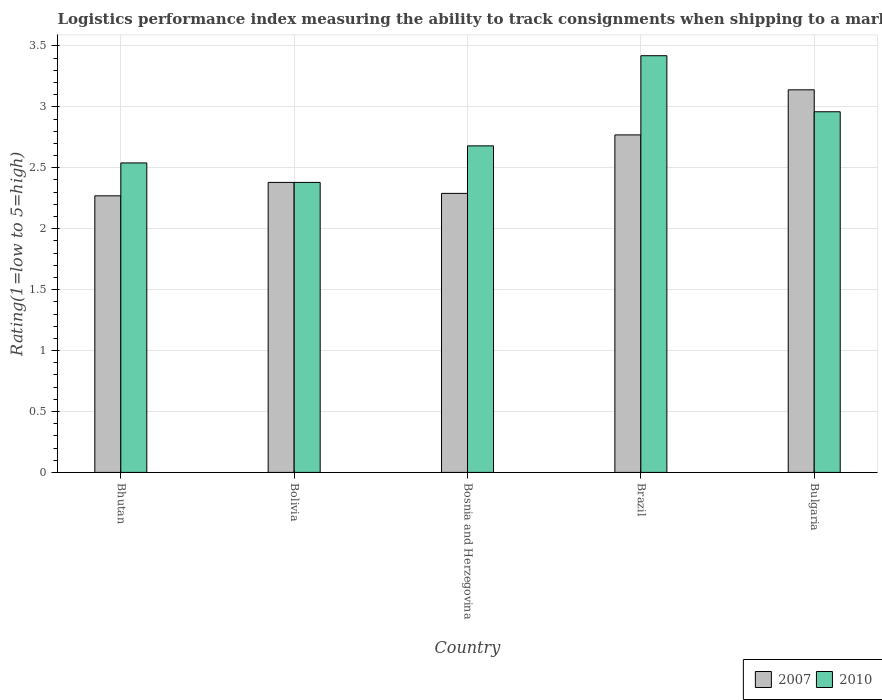How many different coloured bars are there?
Give a very brief answer. 2. How many groups of bars are there?
Offer a very short reply. 5. Are the number of bars on each tick of the X-axis equal?
Your response must be concise. Yes. How many bars are there on the 3rd tick from the right?
Provide a succinct answer. 2. In how many cases, is the number of bars for a given country not equal to the number of legend labels?
Your answer should be very brief. 0. What is the Logistic performance index in 2007 in Bulgaria?
Make the answer very short. 3.14. Across all countries, what is the maximum Logistic performance index in 2010?
Your response must be concise. 3.42. Across all countries, what is the minimum Logistic performance index in 2007?
Give a very brief answer. 2.27. In which country was the Logistic performance index in 2010 minimum?
Provide a succinct answer. Bolivia. What is the total Logistic performance index in 2010 in the graph?
Offer a terse response. 13.98. What is the difference between the Logistic performance index in 2007 in Bhutan and that in Bolivia?
Provide a short and direct response. -0.11. What is the difference between the Logistic performance index in 2007 in Bhutan and the Logistic performance index in 2010 in Brazil?
Provide a short and direct response. -1.15. What is the average Logistic performance index in 2007 per country?
Make the answer very short. 2.57. What is the difference between the Logistic performance index of/in 2007 and Logistic performance index of/in 2010 in Brazil?
Your response must be concise. -0.65. In how many countries, is the Logistic performance index in 2007 greater than 0.1?
Keep it short and to the point. 5. What is the ratio of the Logistic performance index in 2007 in Bolivia to that in Bulgaria?
Your response must be concise. 0.76. Is the Logistic performance index in 2007 in Bosnia and Herzegovina less than that in Bulgaria?
Provide a short and direct response. Yes. What is the difference between the highest and the second highest Logistic performance index in 2010?
Provide a succinct answer. -0.28. What is the difference between the highest and the lowest Logistic performance index in 2007?
Provide a succinct answer. 0.87. In how many countries, is the Logistic performance index in 2007 greater than the average Logistic performance index in 2007 taken over all countries?
Provide a short and direct response. 2. What does the 1st bar from the left in Bulgaria represents?
Provide a short and direct response. 2007. How many countries are there in the graph?
Ensure brevity in your answer.  5. Are the values on the major ticks of Y-axis written in scientific E-notation?
Give a very brief answer. No. How many legend labels are there?
Make the answer very short. 2. How are the legend labels stacked?
Offer a very short reply. Horizontal. What is the title of the graph?
Your response must be concise. Logistics performance index measuring the ability to track consignments when shipping to a market. What is the label or title of the Y-axis?
Offer a terse response. Rating(1=low to 5=high). What is the Rating(1=low to 5=high) of 2007 in Bhutan?
Keep it short and to the point. 2.27. What is the Rating(1=low to 5=high) in 2010 in Bhutan?
Ensure brevity in your answer.  2.54. What is the Rating(1=low to 5=high) in 2007 in Bolivia?
Your answer should be very brief. 2.38. What is the Rating(1=low to 5=high) of 2010 in Bolivia?
Ensure brevity in your answer.  2.38. What is the Rating(1=low to 5=high) in 2007 in Bosnia and Herzegovina?
Provide a short and direct response. 2.29. What is the Rating(1=low to 5=high) in 2010 in Bosnia and Herzegovina?
Make the answer very short. 2.68. What is the Rating(1=low to 5=high) of 2007 in Brazil?
Make the answer very short. 2.77. What is the Rating(1=low to 5=high) of 2010 in Brazil?
Ensure brevity in your answer.  3.42. What is the Rating(1=low to 5=high) of 2007 in Bulgaria?
Make the answer very short. 3.14. What is the Rating(1=low to 5=high) in 2010 in Bulgaria?
Provide a succinct answer. 2.96. Across all countries, what is the maximum Rating(1=low to 5=high) of 2007?
Provide a succinct answer. 3.14. Across all countries, what is the maximum Rating(1=low to 5=high) of 2010?
Your answer should be compact. 3.42. Across all countries, what is the minimum Rating(1=low to 5=high) of 2007?
Ensure brevity in your answer.  2.27. Across all countries, what is the minimum Rating(1=low to 5=high) of 2010?
Provide a short and direct response. 2.38. What is the total Rating(1=low to 5=high) of 2007 in the graph?
Give a very brief answer. 12.85. What is the total Rating(1=low to 5=high) of 2010 in the graph?
Give a very brief answer. 13.98. What is the difference between the Rating(1=low to 5=high) of 2007 in Bhutan and that in Bolivia?
Give a very brief answer. -0.11. What is the difference between the Rating(1=low to 5=high) of 2010 in Bhutan and that in Bolivia?
Your answer should be compact. 0.16. What is the difference between the Rating(1=low to 5=high) in 2007 in Bhutan and that in Bosnia and Herzegovina?
Your answer should be very brief. -0.02. What is the difference between the Rating(1=low to 5=high) in 2010 in Bhutan and that in Bosnia and Herzegovina?
Your response must be concise. -0.14. What is the difference between the Rating(1=low to 5=high) in 2007 in Bhutan and that in Brazil?
Offer a terse response. -0.5. What is the difference between the Rating(1=low to 5=high) in 2010 in Bhutan and that in Brazil?
Your answer should be compact. -0.88. What is the difference between the Rating(1=low to 5=high) of 2007 in Bhutan and that in Bulgaria?
Your response must be concise. -0.87. What is the difference between the Rating(1=low to 5=high) in 2010 in Bhutan and that in Bulgaria?
Offer a terse response. -0.42. What is the difference between the Rating(1=low to 5=high) in 2007 in Bolivia and that in Bosnia and Herzegovina?
Provide a short and direct response. 0.09. What is the difference between the Rating(1=low to 5=high) in 2010 in Bolivia and that in Bosnia and Herzegovina?
Your answer should be very brief. -0.3. What is the difference between the Rating(1=low to 5=high) of 2007 in Bolivia and that in Brazil?
Your answer should be compact. -0.39. What is the difference between the Rating(1=low to 5=high) of 2010 in Bolivia and that in Brazil?
Your response must be concise. -1.04. What is the difference between the Rating(1=low to 5=high) in 2007 in Bolivia and that in Bulgaria?
Your answer should be very brief. -0.76. What is the difference between the Rating(1=low to 5=high) in 2010 in Bolivia and that in Bulgaria?
Offer a terse response. -0.58. What is the difference between the Rating(1=low to 5=high) in 2007 in Bosnia and Herzegovina and that in Brazil?
Provide a short and direct response. -0.48. What is the difference between the Rating(1=low to 5=high) in 2010 in Bosnia and Herzegovina and that in Brazil?
Provide a succinct answer. -0.74. What is the difference between the Rating(1=low to 5=high) in 2007 in Bosnia and Herzegovina and that in Bulgaria?
Make the answer very short. -0.85. What is the difference between the Rating(1=low to 5=high) of 2010 in Bosnia and Herzegovina and that in Bulgaria?
Offer a very short reply. -0.28. What is the difference between the Rating(1=low to 5=high) of 2007 in Brazil and that in Bulgaria?
Make the answer very short. -0.37. What is the difference between the Rating(1=low to 5=high) of 2010 in Brazil and that in Bulgaria?
Ensure brevity in your answer.  0.46. What is the difference between the Rating(1=low to 5=high) in 2007 in Bhutan and the Rating(1=low to 5=high) in 2010 in Bolivia?
Your response must be concise. -0.11. What is the difference between the Rating(1=low to 5=high) in 2007 in Bhutan and the Rating(1=low to 5=high) in 2010 in Bosnia and Herzegovina?
Offer a terse response. -0.41. What is the difference between the Rating(1=low to 5=high) in 2007 in Bhutan and the Rating(1=low to 5=high) in 2010 in Brazil?
Offer a terse response. -1.15. What is the difference between the Rating(1=low to 5=high) of 2007 in Bhutan and the Rating(1=low to 5=high) of 2010 in Bulgaria?
Your response must be concise. -0.69. What is the difference between the Rating(1=low to 5=high) of 2007 in Bolivia and the Rating(1=low to 5=high) of 2010 in Brazil?
Your answer should be compact. -1.04. What is the difference between the Rating(1=low to 5=high) in 2007 in Bolivia and the Rating(1=low to 5=high) in 2010 in Bulgaria?
Your answer should be very brief. -0.58. What is the difference between the Rating(1=low to 5=high) in 2007 in Bosnia and Herzegovina and the Rating(1=low to 5=high) in 2010 in Brazil?
Provide a succinct answer. -1.13. What is the difference between the Rating(1=low to 5=high) in 2007 in Bosnia and Herzegovina and the Rating(1=low to 5=high) in 2010 in Bulgaria?
Offer a terse response. -0.67. What is the difference between the Rating(1=low to 5=high) of 2007 in Brazil and the Rating(1=low to 5=high) of 2010 in Bulgaria?
Your answer should be very brief. -0.19. What is the average Rating(1=low to 5=high) in 2007 per country?
Provide a short and direct response. 2.57. What is the average Rating(1=low to 5=high) of 2010 per country?
Offer a terse response. 2.8. What is the difference between the Rating(1=low to 5=high) in 2007 and Rating(1=low to 5=high) in 2010 in Bhutan?
Provide a short and direct response. -0.27. What is the difference between the Rating(1=low to 5=high) of 2007 and Rating(1=low to 5=high) of 2010 in Bolivia?
Offer a very short reply. 0. What is the difference between the Rating(1=low to 5=high) of 2007 and Rating(1=low to 5=high) of 2010 in Bosnia and Herzegovina?
Offer a very short reply. -0.39. What is the difference between the Rating(1=low to 5=high) of 2007 and Rating(1=low to 5=high) of 2010 in Brazil?
Give a very brief answer. -0.65. What is the difference between the Rating(1=low to 5=high) in 2007 and Rating(1=low to 5=high) in 2010 in Bulgaria?
Give a very brief answer. 0.18. What is the ratio of the Rating(1=low to 5=high) of 2007 in Bhutan to that in Bolivia?
Offer a terse response. 0.95. What is the ratio of the Rating(1=low to 5=high) in 2010 in Bhutan to that in Bolivia?
Offer a terse response. 1.07. What is the ratio of the Rating(1=low to 5=high) in 2007 in Bhutan to that in Bosnia and Herzegovina?
Give a very brief answer. 0.99. What is the ratio of the Rating(1=low to 5=high) in 2010 in Bhutan to that in Bosnia and Herzegovina?
Provide a succinct answer. 0.95. What is the ratio of the Rating(1=low to 5=high) of 2007 in Bhutan to that in Brazil?
Ensure brevity in your answer.  0.82. What is the ratio of the Rating(1=low to 5=high) in 2010 in Bhutan to that in Brazil?
Your answer should be very brief. 0.74. What is the ratio of the Rating(1=low to 5=high) of 2007 in Bhutan to that in Bulgaria?
Offer a terse response. 0.72. What is the ratio of the Rating(1=low to 5=high) in 2010 in Bhutan to that in Bulgaria?
Keep it short and to the point. 0.86. What is the ratio of the Rating(1=low to 5=high) of 2007 in Bolivia to that in Bosnia and Herzegovina?
Keep it short and to the point. 1.04. What is the ratio of the Rating(1=low to 5=high) of 2010 in Bolivia to that in Bosnia and Herzegovina?
Your answer should be compact. 0.89. What is the ratio of the Rating(1=low to 5=high) of 2007 in Bolivia to that in Brazil?
Offer a terse response. 0.86. What is the ratio of the Rating(1=low to 5=high) of 2010 in Bolivia to that in Brazil?
Your response must be concise. 0.7. What is the ratio of the Rating(1=low to 5=high) of 2007 in Bolivia to that in Bulgaria?
Give a very brief answer. 0.76. What is the ratio of the Rating(1=low to 5=high) in 2010 in Bolivia to that in Bulgaria?
Ensure brevity in your answer.  0.8. What is the ratio of the Rating(1=low to 5=high) in 2007 in Bosnia and Herzegovina to that in Brazil?
Make the answer very short. 0.83. What is the ratio of the Rating(1=low to 5=high) of 2010 in Bosnia and Herzegovina to that in Brazil?
Offer a terse response. 0.78. What is the ratio of the Rating(1=low to 5=high) of 2007 in Bosnia and Herzegovina to that in Bulgaria?
Ensure brevity in your answer.  0.73. What is the ratio of the Rating(1=low to 5=high) in 2010 in Bosnia and Herzegovina to that in Bulgaria?
Provide a succinct answer. 0.91. What is the ratio of the Rating(1=low to 5=high) in 2007 in Brazil to that in Bulgaria?
Offer a terse response. 0.88. What is the ratio of the Rating(1=low to 5=high) of 2010 in Brazil to that in Bulgaria?
Offer a very short reply. 1.16. What is the difference between the highest and the second highest Rating(1=low to 5=high) in 2007?
Provide a short and direct response. 0.37. What is the difference between the highest and the second highest Rating(1=low to 5=high) in 2010?
Offer a terse response. 0.46. What is the difference between the highest and the lowest Rating(1=low to 5=high) in 2007?
Make the answer very short. 0.87. 